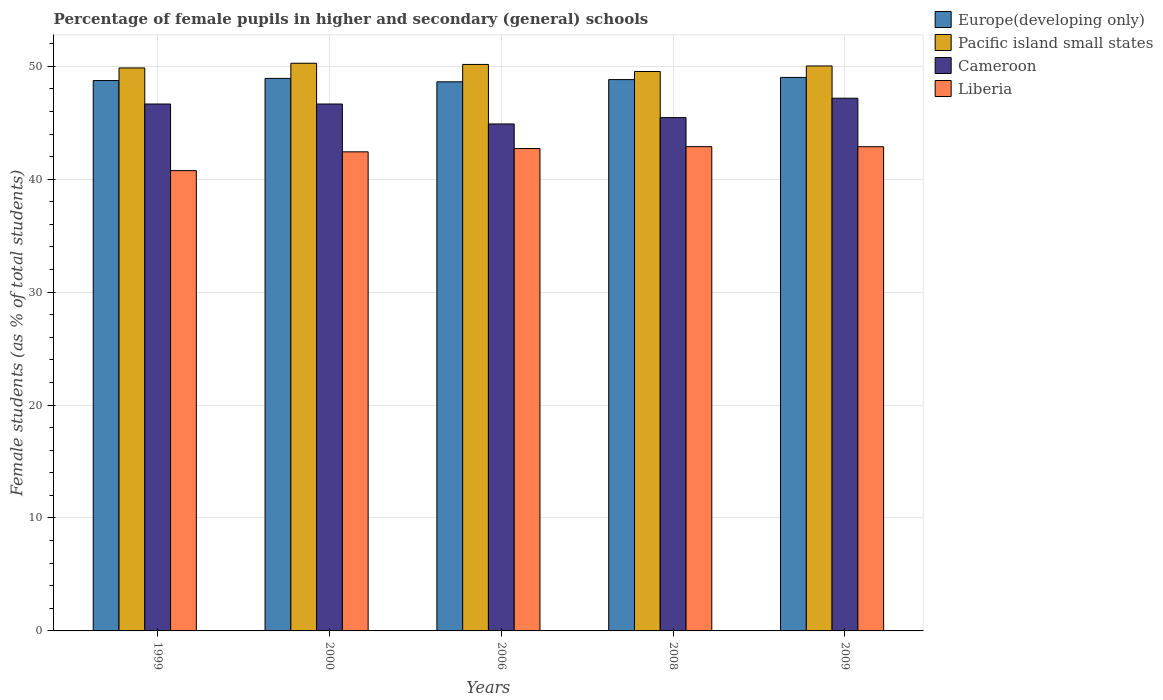How many different coloured bars are there?
Make the answer very short. 4. How many groups of bars are there?
Make the answer very short. 5. How many bars are there on the 2nd tick from the left?
Give a very brief answer. 4. How many bars are there on the 2nd tick from the right?
Make the answer very short. 4. In how many cases, is the number of bars for a given year not equal to the number of legend labels?
Provide a short and direct response. 0. What is the percentage of female pupils in higher and secondary schools in Pacific island small states in 2008?
Your answer should be very brief. 49.54. Across all years, what is the maximum percentage of female pupils in higher and secondary schools in Pacific island small states?
Your answer should be compact. 50.27. Across all years, what is the minimum percentage of female pupils in higher and secondary schools in Pacific island small states?
Ensure brevity in your answer.  49.54. In which year was the percentage of female pupils in higher and secondary schools in Pacific island small states maximum?
Make the answer very short. 2000. In which year was the percentage of female pupils in higher and secondary schools in Liberia minimum?
Keep it short and to the point. 1999. What is the total percentage of female pupils in higher and secondary schools in Liberia in the graph?
Offer a very short reply. 211.67. What is the difference between the percentage of female pupils in higher and secondary schools in Cameroon in 2000 and that in 2006?
Provide a succinct answer. 1.77. What is the difference between the percentage of female pupils in higher and secondary schools in Pacific island small states in 2000 and the percentage of female pupils in higher and secondary schools in Europe(developing only) in 2006?
Your response must be concise. 1.64. What is the average percentage of female pupils in higher and secondary schools in Liberia per year?
Provide a succinct answer. 42.33. In the year 1999, what is the difference between the percentage of female pupils in higher and secondary schools in Cameroon and percentage of female pupils in higher and secondary schools in Liberia?
Your answer should be compact. 5.9. What is the ratio of the percentage of female pupils in higher and secondary schools in Liberia in 2006 to that in 2009?
Keep it short and to the point. 1. What is the difference between the highest and the second highest percentage of female pupils in higher and secondary schools in Europe(developing only)?
Offer a very short reply. 0.09. What is the difference between the highest and the lowest percentage of female pupils in higher and secondary schools in Pacific island small states?
Your answer should be very brief. 0.73. In how many years, is the percentage of female pupils in higher and secondary schools in Cameroon greater than the average percentage of female pupils in higher and secondary schools in Cameroon taken over all years?
Your response must be concise. 3. What does the 1st bar from the left in 2009 represents?
Your answer should be very brief. Europe(developing only). What does the 3rd bar from the right in 2006 represents?
Your answer should be compact. Pacific island small states. How many bars are there?
Your answer should be very brief. 20. What is the difference between two consecutive major ticks on the Y-axis?
Your answer should be very brief. 10. Does the graph contain any zero values?
Ensure brevity in your answer.  No. Does the graph contain grids?
Your answer should be very brief. Yes. Where does the legend appear in the graph?
Give a very brief answer. Top right. How many legend labels are there?
Give a very brief answer. 4. How are the legend labels stacked?
Make the answer very short. Vertical. What is the title of the graph?
Ensure brevity in your answer.  Percentage of female pupils in higher and secondary (general) schools. What is the label or title of the X-axis?
Provide a short and direct response. Years. What is the label or title of the Y-axis?
Provide a succinct answer. Female students (as % of total students). What is the Female students (as % of total students) of Europe(developing only) in 1999?
Ensure brevity in your answer.  48.74. What is the Female students (as % of total students) of Pacific island small states in 1999?
Give a very brief answer. 49.85. What is the Female students (as % of total students) of Cameroon in 1999?
Make the answer very short. 46.66. What is the Female students (as % of total students) of Liberia in 1999?
Offer a terse response. 40.76. What is the Female students (as % of total students) of Europe(developing only) in 2000?
Keep it short and to the point. 48.93. What is the Female students (as % of total students) in Pacific island small states in 2000?
Offer a very short reply. 50.27. What is the Female students (as % of total students) of Cameroon in 2000?
Your response must be concise. 46.66. What is the Female students (as % of total students) in Liberia in 2000?
Give a very brief answer. 42.42. What is the Female students (as % of total students) of Europe(developing only) in 2006?
Your answer should be very brief. 48.63. What is the Female students (as % of total students) in Pacific island small states in 2006?
Your answer should be compact. 50.17. What is the Female students (as % of total students) in Cameroon in 2006?
Offer a very short reply. 44.89. What is the Female students (as % of total students) in Liberia in 2006?
Keep it short and to the point. 42.72. What is the Female students (as % of total students) of Europe(developing only) in 2008?
Keep it short and to the point. 48.82. What is the Female students (as % of total students) in Pacific island small states in 2008?
Your answer should be compact. 49.54. What is the Female students (as % of total students) of Cameroon in 2008?
Your answer should be compact. 45.46. What is the Female students (as % of total students) in Liberia in 2008?
Your response must be concise. 42.88. What is the Female students (as % of total students) in Europe(developing only) in 2009?
Provide a short and direct response. 49.02. What is the Female students (as % of total students) in Pacific island small states in 2009?
Your answer should be very brief. 50.03. What is the Female students (as % of total students) in Cameroon in 2009?
Provide a short and direct response. 47.17. What is the Female students (as % of total students) of Liberia in 2009?
Keep it short and to the point. 42.88. Across all years, what is the maximum Female students (as % of total students) of Europe(developing only)?
Offer a terse response. 49.02. Across all years, what is the maximum Female students (as % of total students) in Pacific island small states?
Provide a succinct answer. 50.27. Across all years, what is the maximum Female students (as % of total students) in Cameroon?
Ensure brevity in your answer.  47.17. Across all years, what is the maximum Female students (as % of total students) in Liberia?
Provide a succinct answer. 42.88. Across all years, what is the minimum Female students (as % of total students) of Europe(developing only)?
Your response must be concise. 48.63. Across all years, what is the minimum Female students (as % of total students) in Pacific island small states?
Ensure brevity in your answer.  49.54. Across all years, what is the minimum Female students (as % of total students) of Cameroon?
Keep it short and to the point. 44.89. Across all years, what is the minimum Female students (as % of total students) of Liberia?
Offer a very short reply. 40.76. What is the total Female students (as % of total students) in Europe(developing only) in the graph?
Give a very brief answer. 244.13. What is the total Female students (as % of total students) of Pacific island small states in the graph?
Your answer should be compact. 249.86. What is the total Female students (as % of total students) of Cameroon in the graph?
Your answer should be compact. 230.84. What is the total Female students (as % of total students) in Liberia in the graph?
Make the answer very short. 211.67. What is the difference between the Female students (as % of total students) of Europe(developing only) in 1999 and that in 2000?
Your response must be concise. -0.19. What is the difference between the Female students (as % of total students) of Pacific island small states in 1999 and that in 2000?
Your response must be concise. -0.41. What is the difference between the Female students (as % of total students) of Cameroon in 1999 and that in 2000?
Provide a succinct answer. -0. What is the difference between the Female students (as % of total students) of Liberia in 1999 and that in 2000?
Offer a very short reply. -1.66. What is the difference between the Female students (as % of total students) in Europe(developing only) in 1999 and that in 2006?
Ensure brevity in your answer.  0.11. What is the difference between the Female students (as % of total students) in Pacific island small states in 1999 and that in 2006?
Provide a short and direct response. -0.31. What is the difference between the Female students (as % of total students) in Cameroon in 1999 and that in 2006?
Make the answer very short. 1.77. What is the difference between the Female students (as % of total students) in Liberia in 1999 and that in 2006?
Make the answer very short. -1.96. What is the difference between the Female students (as % of total students) of Europe(developing only) in 1999 and that in 2008?
Your response must be concise. -0.08. What is the difference between the Female students (as % of total students) in Pacific island small states in 1999 and that in 2008?
Make the answer very short. 0.31. What is the difference between the Female students (as % of total students) of Cameroon in 1999 and that in 2008?
Give a very brief answer. 1.21. What is the difference between the Female students (as % of total students) of Liberia in 1999 and that in 2008?
Provide a short and direct response. -2.12. What is the difference between the Female students (as % of total students) of Europe(developing only) in 1999 and that in 2009?
Your response must be concise. -0.28. What is the difference between the Female students (as % of total students) of Pacific island small states in 1999 and that in 2009?
Ensure brevity in your answer.  -0.18. What is the difference between the Female students (as % of total students) in Cameroon in 1999 and that in 2009?
Keep it short and to the point. -0.51. What is the difference between the Female students (as % of total students) in Liberia in 1999 and that in 2009?
Ensure brevity in your answer.  -2.12. What is the difference between the Female students (as % of total students) in Europe(developing only) in 2000 and that in 2006?
Ensure brevity in your answer.  0.3. What is the difference between the Female students (as % of total students) in Pacific island small states in 2000 and that in 2006?
Your answer should be compact. 0.1. What is the difference between the Female students (as % of total students) in Cameroon in 2000 and that in 2006?
Offer a very short reply. 1.77. What is the difference between the Female students (as % of total students) in Liberia in 2000 and that in 2006?
Your response must be concise. -0.29. What is the difference between the Female students (as % of total students) of Europe(developing only) in 2000 and that in 2008?
Your answer should be compact. 0.11. What is the difference between the Female students (as % of total students) of Pacific island small states in 2000 and that in 2008?
Provide a succinct answer. 0.73. What is the difference between the Female students (as % of total students) in Cameroon in 2000 and that in 2008?
Your answer should be very brief. 1.21. What is the difference between the Female students (as % of total students) in Liberia in 2000 and that in 2008?
Give a very brief answer. -0.46. What is the difference between the Female students (as % of total students) of Europe(developing only) in 2000 and that in 2009?
Ensure brevity in your answer.  -0.09. What is the difference between the Female students (as % of total students) of Pacific island small states in 2000 and that in 2009?
Give a very brief answer. 0.24. What is the difference between the Female students (as % of total students) of Cameroon in 2000 and that in 2009?
Make the answer very short. -0.51. What is the difference between the Female students (as % of total students) of Liberia in 2000 and that in 2009?
Make the answer very short. -0.46. What is the difference between the Female students (as % of total students) in Europe(developing only) in 2006 and that in 2008?
Offer a terse response. -0.2. What is the difference between the Female students (as % of total students) in Pacific island small states in 2006 and that in 2008?
Make the answer very short. 0.63. What is the difference between the Female students (as % of total students) of Cameroon in 2006 and that in 2008?
Your answer should be very brief. -0.56. What is the difference between the Female students (as % of total students) in Liberia in 2006 and that in 2008?
Provide a short and direct response. -0.17. What is the difference between the Female students (as % of total students) in Europe(developing only) in 2006 and that in 2009?
Ensure brevity in your answer.  -0.39. What is the difference between the Female students (as % of total students) of Pacific island small states in 2006 and that in 2009?
Your response must be concise. 0.13. What is the difference between the Female students (as % of total students) in Cameroon in 2006 and that in 2009?
Provide a succinct answer. -2.28. What is the difference between the Female students (as % of total students) in Liberia in 2006 and that in 2009?
Offer a terse response. -0.16. What is the difference between the Female students (as % of total students) of Europe(developing only) in 2008 and that in 2009?
Give a very brief answer. -0.19. What is the difference between the Female students (as % of total students) of Pacific island small states in 2008 and that in 2009?
Your answer should be very brief. -0.49. What is the difference between the Female students (as % of total students) in Cameroon in 2008 and that in 2009?
Your answer should be very brief. -1.72. What is the difference between the Female students (as % of total students) of Liberia in 2008 and that in 2009?
Keep it short and to the point. 0. What is the difference between the Female students (as % of total students) of Europe(developing only) in 1999 and the Female students (as % of total students) of Pacific island small states in 2000?
Ensure brevity in your answer.  -1.53. What is the difference between the Female students (as % of total students) in Europe(developing only) in 1999 and the Female students (as % of total students) in Cameroon in 2000?
Your answer should be very brief. 2.08. What is the difference between the Female students (as % of total students) of Europe(developing only) in 1999 and the Female students (as % of total students) of Liberia in 2000?
Ensure brevity in your answer.  6.31. What is the difference between the Female students (as % of total students) of Pacific island small states in 1999 and the Female students (as % of total students) of Cameroon in 2000?
Provide a short and direct response. 3.19. What is the difference between the Female students (as % of total students) in Pacific island small states in 1999 and the Female students (as % of total students) in Liberia in 2000?
Offer a very short reply. 7.43. What is the difference between the Female students (as % of total students) of Cameroon in 1999 and the Female students (as % of total students) of Liberia in 2000?
Offer a very short reply. 4.24. What is the difference between the Female students (as % of total students) in Europe(developing only) in 1999 and the Female students (as % of total students) in Pacific island small states in 2006?
Your answer should be compact. -1.43. What is the difference between the Female students (as % of total students) in Europe(developing only) in 1999 and the Female students (as % of total students) in Cameroon in 2006?
Ensure brevity in your answer.  3.84. What is the difference between the Female students (as % of total students) of Europe(developing only) in 1999 and the Female students (as % of total students) of Liberia in 2006?
Offer a terse response. 6.02. What is the difference between the Female students (as % of total students) of Pacific island small states in 1999 and the Female students (as % of total students) of Cameroon in 2006?
Your answer should be compact. 4.96. What is the difference between the Female students (as % of total students) of Pacific island small states in 1999 and the Female students (as % of total students) of Liberia in 2006?
Keep it short and to the point. 7.14. What is the difference between the Female students (as % of total students) in Cameroon in 1999 and the Female students (as % of total students) in Liberia in 2006?
Provide a short and direct response. 3.94. What is the difference between the Female students (as % of total students) in Europe(developing only) in 1999 and the Female students (as % of total students) in Pacific island small states in 2008?
Ensure brevity in your answer.  -0.8. What is the difference between the Female students (as % of total students) in Europe(developing only) in 1999 and the Female students (as % of total students) in Cameroon in 2008?
Your answer should be very brief. 3.28. What is the difference between the Female students (as % of total students) in Europe(developing only) in 1999 and the Female students (as % of total students) in Liberia in 2008?
Offer a very short reply. 5.86. What is the difference between the Female students (as % of total students) of Pacific island small states in 1999 and the Female students (as % of total students) of Cameroon in 2008?
Your answer should be very brief. 4.4. What is the difference between the Female students (as % of total students) of Pacific island small states in 1999 and the Female students (as % of total students) of Liberia in 2008?
Make the answer very short. 6.97. What is the difference between the Female students (as % of total students) in Cameroon in 1999 and the Female students (as % of total students) in Liberia in 2008?
Ensure brevity in your answer.  3.78. What is the difference between the Female students (as % of total students) of Europe(developing only) in 1999 and the Female students (as % of total students) of Pacific island small states in 2009?
Offer a terse response. -1.29. What is the difference between the Female students (as % of total students) in Europe(developing only) in 1999 and the Female students (as % of total students) in Cameroon in 2009?
Provide a succinct answer. 1.57. What is the difference between the Female students (as % of total students) of Europe(developing only) in 1999 and the Female students (as % of total students) of Liberia in 2009?
Your answer should be compact. 5.86. What is the difference between the Female students (as % of total students) of Pacific island small states in 1999 and the Female students (as % of total students) of Cameroon in 2009?
Provide a succinct answer. 2.68. What is the difference between the Female students (as % of total students) in Pacific island small states in 1999 and the Female students (as % of total students) in Liberia in 2009?
Provide a short and direct response. 6.97. What is the difference between the Female students (as % of total students) of Cameroon in 1999 and the Female students (as % of total students) of Liberia in 2009?
Offer a very short reply. 3.78. What is the difference between the Female students (as % of total students) in Europe(developing only) in 2000 and the Female students (as % of total students) in Pacific island small states in 2006?
Your response must be concise. -1.24. What is the difference between the Female students (as % of total students) in Europe(developing only) in 2000 and the Female students (as % of total students) in Cameroon in 2006?
Keep it short and to the point. 4.04. What is the difference between the Female students (as % of total students) in Europe(developing only) in 2000 and the Female students (as % of total students) in Liberia in 2006?
Provide a short and direct response. 6.21. What is the difference between the Female students (as % of total students) in Pacific island small states in 2000 and the Female students (as % of total students) in Cameroon in 2006?
Ensure brevity in your answer.  5.38. What is the difference between the Female students (as % of total students) of Pacific island small states in 2000 and the Female students (as % of total students) of Liberia in 2006?
Your response must be concise. 7.55. What is the difference between the Female students (as % of total students) in Cameroon in 2000 and the Female students (as % of total students) in Liberia in 2006?
Your answer should be compact. 3.94. What is the difference between the Female students (as % of total students) in Europe(developing only) in 2000 and the Female students (as % of total students) in Pacific island small states in 2008?
Offer a very short reply. -0.61. What is the difference between the Female students (as % of total students) in Europe(developing only) in 2000 and the Female students (as % of total students) in Cameroon in 2008?
Offer a terse response. 3.47. What is the difference between the Female students (as % of total students) of Europe(developing only) in 2000 and the Female students (as % of total students) of Liberia in 2008?
Make the answer very short. 6.05. What is the difference between the Female students (as % of total students) of Pacific island small states in 2000 and the Female students (as % of total students) of Cameroon in 2008?
Provide a succinct answer. 4.81. What is the difference between the Female students (as % of total students) in Pacific island small states in 2000 and the Female students (as % of total students) in Liberia in 2008?
Ensure brevity in your answer.  7.39. What is the difference between the Female students (as % of total students) of Cameroon in 2000 and the Female students (as % of total students) of Liberia in 2008?
Provide a short and direct response. 3.78. What is the difference between the Female students (as % of total students) in Europe(developing only) in 2000 and the Female students (as % of total students) in Pacific island small states in 2009?
Ensure brevity in your answer.  -1.1. What is the difference between the Female students (as % of total students) of Europe(developing only) in 2000 and the Female students (as % of total students) of Cameroon in 2009?
Give a very brief answer. 1.76. What is the difference between the Female students (as % of total students) of Europe(developing only) in 2000 and the Female students (as % of total students) of Liberia in 2009?
Offer a very short reply. 6.05. What is the difference between the Female students (as % of total students) in Pacific island small states in 2000 and the Female students (as % of total students) in Cameroon in 2009?
Make the answer very short. 3.1. What is the difference between the Female students (as % of total students) in Pacific island small states in 2000 and the Female students (as % of total students) in Liberia in 2009?
Give a very brief answer. 7.39. What is the difference between the Female students (as % of total students) of Cameroon in 2000 and the Female students (as % of total students) of Liberia in 2009?
Offer a terse response. 3.78. What is the difference between the Female students (as % of total students) in Europe(developing only) in 2006 and the Female students (as % of total students) in Pacific island small states in 2008?
Provide a succinct answer. -0.91. What is the difference between the Female students (as % of total students) of Europe(developing only) in 2006 and the Female students (as % of total students) of Cameroon in 2008?
Offer a very short reply. 3.17. What is the difference between the Female students (as % of total students) of Europe(developing only) in 2006 and the Female students (as % of total students) of Liberia in 2008?
Make the answer very short. 5.74. What is the difference between the Female students (as % of total students) of Pacific island small states in 2006 and the Female students (as % of total students) of Cameroon in 2008?
Your response must be concise. 4.71. What is the difference between the Female students (as % of total students) of Pacific island small states in 2006 and the Female students (as % of total students) of Liberia in 2008?
Your response must be concise. 7.28. What is the difference between the Female students (as % of total students) of Cameroon in 2006 and the Female students (as % of total students) of Liberia in 2008?
Make the answer very short. 2.01. What is the difference between the Female students (as % of total students) of Europe(developing only) in 2006 and the Female students (as % of total students) of Pacific island small states in 2009?
Provide a succinct answer. -1.41. What is the difference between the Female students (as % of total students) of Europe(developing only) in 2006 and the Female students (as % of total students) of Cameroon in 2009?
Offer a very short reply. 1.45. What is the difference between the Female students (as % of total students) of Europe(developing only) in 2006 and the Female students (as % of total students) of Liberia in 2009?
Give a very brief answer. 5.75. What is the difference between the Female students (as % of total students) in Pacific island small states in 2006 and the Female students (as % of total students) in Cameroon in 2009?
Offer a terse response. 2.99. What is the difference between the Female students (as % of total students) of Pacific island small states in 2006 and the Female students (as % of total students) of Liberia in 2009?
Give a very brief answer. 7.29. What is the difference between the Female students (as % of total students) in Cameroon in 2006 and the Female students (as % of total students) in Liberia in 2009?
Your answer should be very brief. 2.01. What is the difference between the Female students (as % of total students) in Europe(developing only) in 2008 and the Female students (as % of total students) in Pacific island small states in 2009?
Your response must be concise. -1.21. What is the difference between the Female students (as % of total students) in Europe(developing only) in 2008 and the Female students (as % of total students) in Cameroon in 2009?
Keep it short and to the point. 1.65. What is the difference between the Female students (as % of total students) of Europe(developing only) in 2008 and the Female students (as % of total students) of Liberia in 2009?
Keep it short and to the point. 5.94. What is the difference between the Female students (as % of total students) in Pacific island small states in 2008 and the Female students (as % of total students) in Cameroon in 2009?
Give a very brief answer. 2.37. What is the difference between the Female students (as % of total students) in Pacific island small states in 2008 and the Female students (as % of total students) in Liberia in 2009?
Your answer should be compact. 6.66. What is the difference between the Female students (as % of total students) in Cameroon in 2008 and the Female students (as % of total students) in Liberia in 2009?
Your answer should be compact. 2.58. What is the average Female students (as % of total students) in Europe(developing only) per year?
Give a very brief answer. 48.83. What is the average Female students (as % of total students) of Pacific island small states per year?
Make the answer very short. 49.97. What is the average Female students (as % of total students) of Cameroon per year?
Offer a very short reply. 46.17. What is the average Female students (as % of total students) of Liberia per year?
Provide a succinct answer. 42.33. In the year 1999, what is the difference between the Female students (as % of total students) of Europe(developing only) and Female students (as % of total students) of Pacific island small states?
Your response must be concise. -1.12. In the year 1999, what is the difference between the Female students (as % of total students) in Europe(developing only) and Female students (as % of total students) in Cameroon?
Provide a short and direct response. 2.08. In the year 1999, what is the difference between the Female students (as % of total students) in Europe(developing only) and Female students (as % of total students) in Liberia?
Ensure brevity in your answer.  7.98. In the year 1999, what is the difference between the Female students (as % of total students) of Pacific island small states and Female students (as % of total students) of Cameroon?
Give a very brief answer. 3.19. In the year 1999, what is the difference between the Female students (as % of total students) in Pacific island small states and Female students (as % of total students) in Liberia?
Your answer should be very brief. 9.09. In the year 1999, what is the difference between the Female students (as % of total students) in Cameroon and Female students (as % of total students) in Liberia?
Ensure brevity in your answer.  5.9. In the year 2000, what is the difference between the Female students (as % of total students) of Europe(developing only) and Female students (as % of total students) of Pacific island small states?
Your response must be concise. -1.34. In the year 2000, what is the difference between the Female students (as % of total students) of Europe(developing only) and Female students (as % of total students) of Cameroon?
Your answer should be compact. 2.27. In the year 2000, what is the difference between the Female students (as % of total students) of Europe(developing only) and Female students (as % of total students) of Liberia?
Offer a very short reply. 6.5. In the year 2000, what is the difference between the Female students (as % of total students) of Pacific island small states and Female students (as % of total students) of Cameroon?
Offer a terse response. 3.61. In the year 2000, what is the difference between the Female students (as % of total students) in Pacific island small states and Female students (as % of total students) in Liberia?
Keep it short and to the point. 7.84. In the year 2000, what is the difference between the Female students (as % of total students) of Cameroon and Female students (as % of total students) of Liberia?
Your answer should be very brief. 4.24. In the year 2006, what is the difference between the Female students (as % of total students) in Europe(developing only) and Female students (as % of total students) in Pacific island small states?
Your answer should be very brief. -1.54. In the year 2006, what is the difference between the Female students (as % of total students) in Europe(developing only) and Female students (as % of total students) in Cameroon?
Make the answer very short. 3.73. In the year 2006, what is the difference between the Female students (as % of total students) of Europe(developing only) and Female students (as % of total students) of Liberia?
Make the answer very short. 5.91. In the year 2006, what is the difference between the Female students (as % of total students) in Pacific island small states and Female students (as % of total students) in Cameroon?
Your response must be concise. 5.27. In the year 2006, what is the difference between the Female students (as % of total students) of Pacific island small states and Female students (as % of total students) of Liberia?
Keep it short and to the point. 7.45. In the year 2006, what is the difference between the Female students (as % of total students) in Cameroon and Female students (as % of total students) in Liberia?
Give a very brief answer. 2.18. In the year 2008, what is the difference between the Female students (as % of total students) of Europe(developing only) and Female students (as % of total students) of Pacific island small states?
Your answer should be very brief. -0.72. In the year 2008, what is the difference between the Female students (as % of total students) in Europe(developing only) and Female students (as % of total students) in Cameroon?
Offer a very short reply. 3.37. In the year 2008, what is the difference between the Female students (as % of total students) of Europe(developing only) and Female students (as % of total students) of Liberia?
Offer a terse response. 5.94. In the year 2008, what is the difference between the Female students (as % of total students) in Pacific island small states and Female students (as % of total students) in Cameroon?
Your answer should be compact. 4.08. In the year 2008, what is the difference between the Female students (as % of total students) of Pacific island small states and Female students (as % of total students) of Liberia?
Provide a succinct answer. 6.66. In the year 2008, what is the difference between the Female students (as % of total students) in Cameroon and Female students (as % of total students) in Liberia?
Offer a very short reply. 2.57. In the year 2009, what is the difference between the Female students (as % of total students) of Europe(developing only) and Female students (as % of total students) of Pacific island small states?
Make the answer very short. -1.02. In the year 2009, what is the difference between the Female students (as % of total students) of Europe(developing only) and Female students (as % of total students) of Cameroon?
Your answer should be very brief. 1.84. In the year 2009, what is the difference between the Female students (as % of total students) in Europe(developing only) and Female students (as % of total students) in Liberia?
Provide a succinct answer. 6.13. In the year 2009, what is the difference between the Female students (as % of total students) of Pacific island small states and Female students (as % of total students) of Cameroon?
Your response must be concise. 2.86. In the year 2009, what is the difference between the Female students (as % of total students) of Pacific island small states and Female students (as % of total students) of Liberia?
Offer a very short reply. 7.15. In the year 2009, what is the difference between the Female students (as % of total students) of Cameroon and Female students (as % of total students) of Liberia?
Your answer should be compact. 4.29. What is the ratio of the Female students (as % of total students) of Europe(developing only) in 1999 to that in 2000?
Keep it short and to the point. 1. What is the ratio of the Female students (as % of total students) in Pacific island small states in 1999 to that in 2000?
Provide a short and direct response. 0.99. What is the ratio of the Female students (as % of total students) in Cameroon in 1999 to that in 2000?
Give a very brief answer. 1. What is the ratio of the Female students (as % of total students) in Liberia in 1999 to that in 2000?
Give a very brief answer. 0.96. What is the ratio of the Female students (as % of total students) of Pacific island small states in 1999 to that in 2006?
Give a very brief answer. 0.99. What is the ratio of the Female students (as % of total students) in Cameroon in 1999 to that in 2006?
Ensure brevity in your answer.  1.04. What is the ratio of the Female students (as % of total students) in Liberia in 1999 to that in 2006?
Offer a terse response. 0.95. What is the ratio of the Female students (as % of total students) of Pacific island small states in 1999 to that in 2008?
Provide a short and direct response. 1.01. What is the ratio of the Female students (as % of total students) of Cameroon in 1999 to that in 2008?
Make the answer very short. 1.03. What is the ratio of the Female students (as % of total students) of Liberia in 1999 to that in 2008?
Provide a succinct answer. 0.95. What is the ratio of the Female students (as % of total students) of Europe(developing only) in 1999 to that in 2009?
Your answer should be very brief. 0.99. What is the ratio of the Female students (as % of total students) of Pacific island small states in 1999 to that in 2009?
Give a very brief answer. 1. What is the ratio of the Female students (as % of total students) of Cameroon in 1999 to that in 2009?
Your answer should be compact. 0.99. What is the ratio of the Female students (as % of total students) in Liberia in 1999 to that in 2009?
Your answer should be compact. 0.95. What is the ratio of the Female students (as % of total students) of Europe(developing only) in 2000 to that in 2006?
Ensure brevity in your answer.  1.01. What is the ratio of the Female students (as % of total students) of Cameroon in 2000 to that in 2006?
Ensure brevity in your answer.  1.04. What is the ratio of the Female students (as % of total students) in Liberia in 2000 to that in 2006?
Give a very brief answer. 0.99. What is the ratio of the Female students (as % of total students) of Pacific island small states in 2000 to that in 2008?
Provide a succinct answer. 1.01. What is the ratio of the Female students (as % of total students) in Cameroon in 2000 to that in 2008?
Provide a short and direct response. 1.03. What is the ratio of the Female students (as % of total students) in Liberia in 2000 to that in 2008?
Provide a short and direct response. 0.99. What is the ratio of the Female students (as % of total students) of Europe(developing only) in 2000 to that in 2009?
Your answer should be very brief. 1. What is the ratio of the Female students (as % of total students) of Pacific island small states in 2000 to that in 2009?
Ensure brevity in your answer.  1. What is the ratio of the Female students (as % of total students) of Cameroon in 2000 to that in 2009?
Give a very brief answer. 0.99. What is the ratio of the Female students (as % of total students) in Liberia in 2000 to that in 2009?
Provide a succinct answer. 0.99. What is the ratio of the Female students (as % of total students) in Pacific island small states in 2006 to that in 2008?
Offer a terse response. 1.01. What is the ratio of the Female students (as % of total students) of Cameroon in 2006 to that in 2008?
Your response must be concise. 0.99. What is the ratio of the Female students (as % of total students) in Liberia in 2006 to that in 2008?
Your answer should be compact. 1. What is the ratio of the Female students (as % of total students) of Pacific island small states in 2006 to that in 2009?
Your answer should be compact. 1. What is the ratio of the Female students (as % of total students) of Cameroon in 2006 to that in 2009?
Provide a succinct answer. 0.95. What is the ratio of the Female students (as % of total students) of Liberia in 2006 to that in 2009?
Offer a terse response. 1. What is the ratio of the Female students (as % of total students) of Pacific island small states in 2008 to that in 2009?
Provide a short and direct response. 0.99. What is the ratio of the Female students (as % of total students) in Cameroon in 2008 to that in 2009?
Offer a terse response. 0.96. What is the ratio of the Female students (as % of total students) of Liberia in 2008 to that in 2009?
Give a very brief answer. 1. What is the difference between the highest and the second highest Female students (as % of total students) in Europe(developing only)?
Give a very brief answer. 0.09. What is the difference between the highest and the second highest Female students (as % of total students) of Pacific island small states?
Make the answer very short. 0.1. What is the difference between the highest and the second highest Female students (as % of total students) in Cameroon?
Provide a succinct answer. 0.51. What is the difference between the highest and the second highest Female students (as % of total students) in Liberia?
Ensure brevity in your answer.  0. What is the difference between the highest and the lowest Female students (as % of total students) in Europe(developing only)?
Your answer should be compact. 0.39. What is the difference between the highest and the lowest Female students (as % of total students) of Pacific island small states?
Make the answer very short. 0.73. What is the difference between the highest and the lowest Female students (as % of total students) in Cameroon?
Provide a short and direct response. 2.28. What is the difference between the highest and the lowest Female students (as % of total students) of Liberia?
Keep it short and to the point. 2.12. 